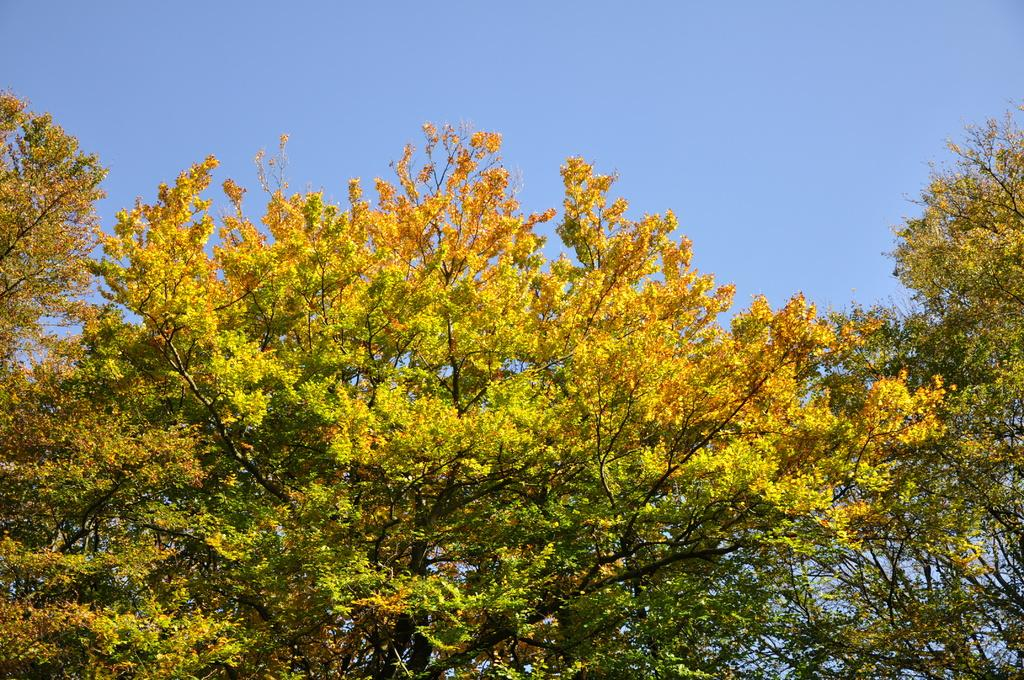What type of vegetation can be seen in the image? There are trees in the image. What is visible behind the trees in the image? The sky is visible behind the trees in the image. How many laborers are working in the cornfield in the image? There are no laborers or cornfields present in the image; it only features trees and the sky. What type of creature can be seen interacting with the trees in the image? There is no creature present in the image; only trees and the sky are visible. 